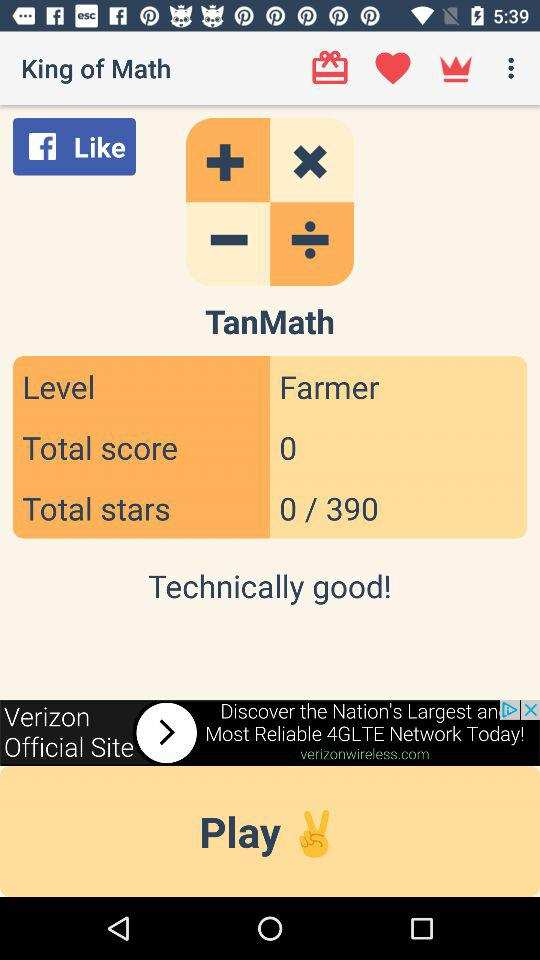How many total stars are there? There are 390 total stars. 